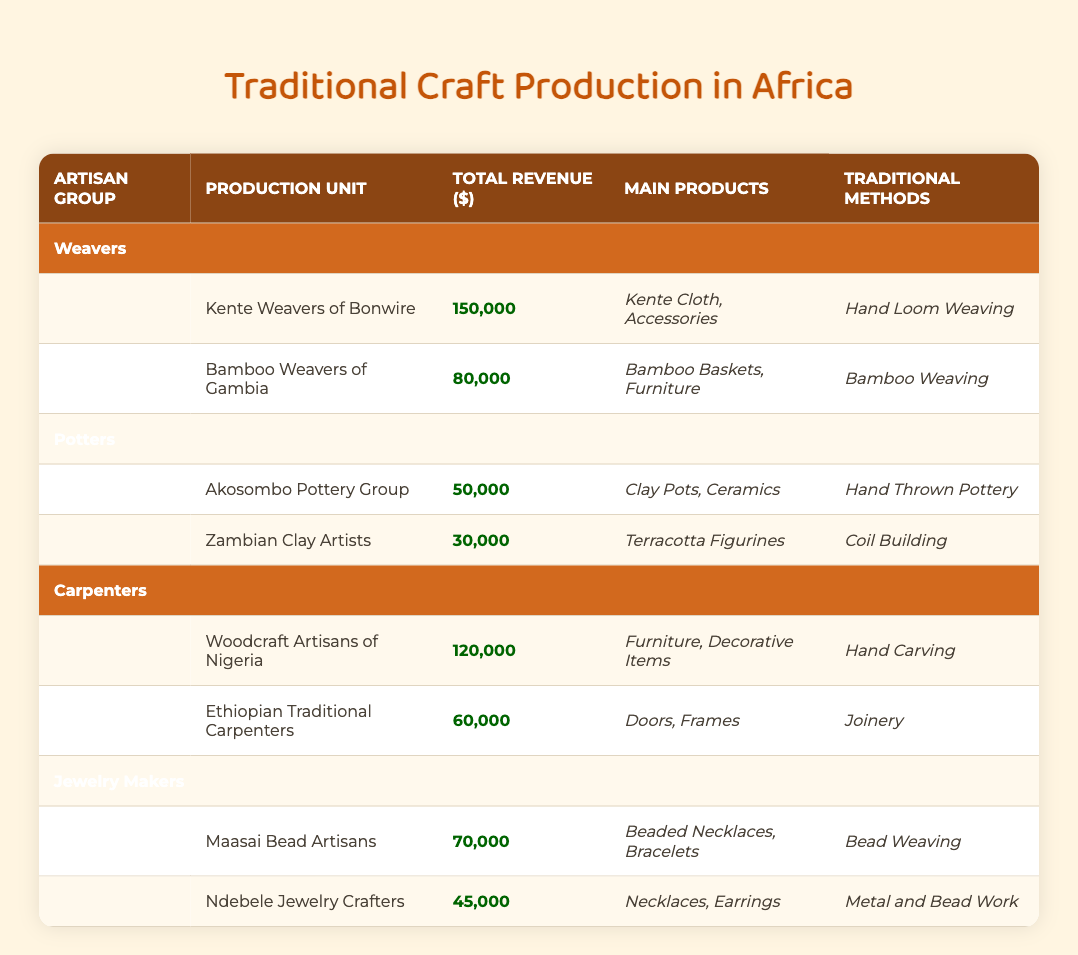What is the total revenue generated by the Kente Weavers of Bonwire? The table indicates that the Kente Weavers of Bonwire have a total revenue of 150,000 dollars, which is stated directly in their respective row.
Answer: 150000 Which artisan group has the highest total revenue? By comparing the total revenue figures across all artisan groups, the Woodcraft Artisans of Nigeria have the highest revenue at 120,000 dollars, as seen in their entry in the Carpenters section.
Answer: Woodcraft Artisans of Nigeria How much revenue do the Potters generate in total? The total revenue for the Potters can be calculated by summing the individual revenues from both production units: 50,000 (Akosombo Pottery Group) + 30,000 (Zambian Clay Artists) = 80,000 dollars.
Answer: 80000 Do the Ndebele Jewelry Crafters have higher total revenue than the Akosombo Pottery Group? The Ndebele Jewelry Crafters have a total revenue of 45,000 dollars while the Akosombo Pottery Group has 50,000 dollars. Since 45,000 is less than 50,000, this statement is false.
Answer: No What is the average total revenue of the Weavers? The total revenues for the Weavers (Kente Weavers of Bonwire: 150,000 and Bamboo Weavers of Gambia: 80,000) add up to 230,000 dollars. There are 2 production units, so the average is 230,000 / 2 = 115,000 dollars.
Answer: 115000 Which traditional method is used by the Woodcraft Artisans of Nigeria? The table shows that the Woodcraft Artisans of Nigeria utilize "Hand Carving" as their traditional method, which is indicated in the corresponding row.
Answer: Hand Carving What is the difference in revenue between the highest and the lowest earning artisans? The highest revenue is from the Woodcraft Artisans of Nigeria with 120,000 dollars, and the lowest is from Zambian Clay Artists with 30,000 dollars. To find the difference: 120,000 - 30,000 = 90,000 dollars.
Answer: 90000 How many artisan groups have a total revenue greater than 50,000 dollars? The Weavers and Carpenters artisan groups have individual units with revenues greater than 50,000 dollars. Specifically, there are 4 production units (Kente Weavers of Bonwire, Bamboo Weavers of Gambia, Woodcraft Artisans of Nigeria) generating more than 50,000 dollars.
Answer: 4 